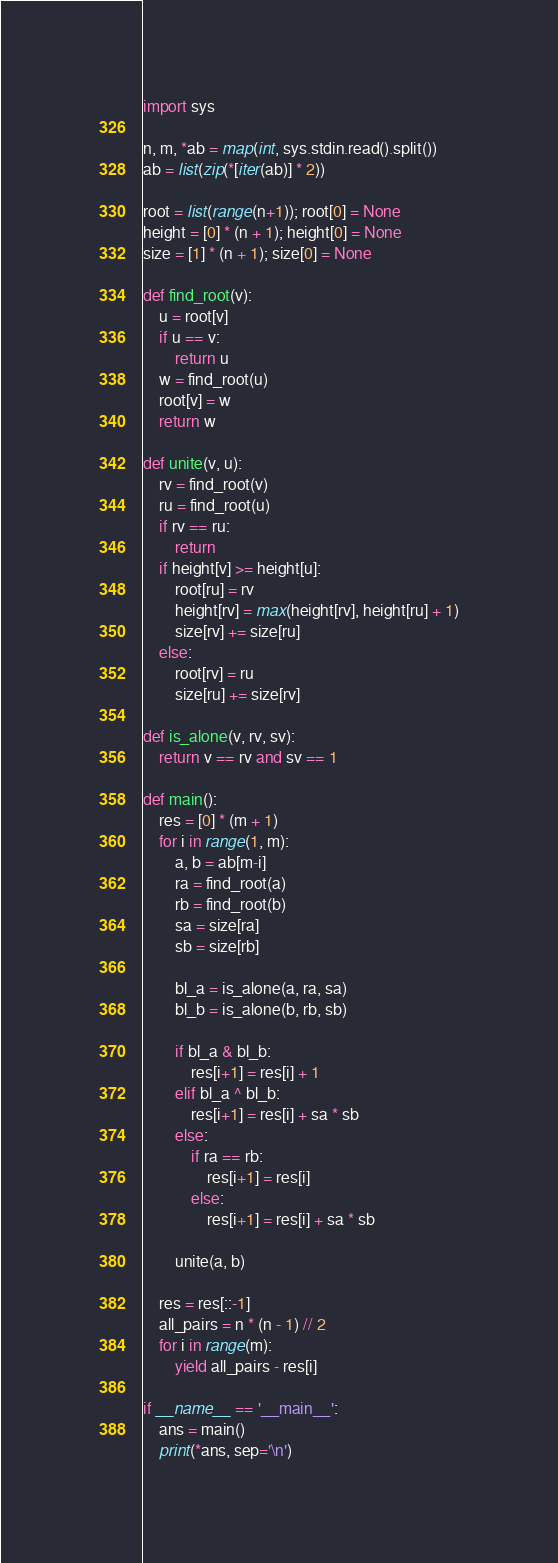Convert code to text. <code><loc_0><loc_0><loc_500><loc_500><_Python_>import sys

n, m, *ab = map(int, sys.stdin.read().split())
ab = list(zip(*[iter(ab)] * 2))

root = list(range(n+1)); root[0] = None
height = [0] * (n + 1); height[0] = None
size = [1] * (n + 1); size[0] = None

def find_root(v):
    u = root[v]
    if u == v:
        return u
    w = find_root(u)
    root[v] = w
    return w

def unite(v, u):
    rv = find_root(v)
    ru = find_root(u)
    if rv == ru:
        return
    if height[v] >= height[u]:
        root[ru] = rv
        height[rv] = max(height[rv], height[ru] + 1)
        size[rv] += size[ru]
    else:
        root[rv] = ru
        size[ru] += size[rv]

def is_alone(v, rv, sv):
    return v == rv and sv == 1

def main():
    res = [0] * (m + 1)
    for i in range(1, m):
        a, b = ab[m-i]
        ra = find_root(a)
        rb = find_root(b)
        sa = size[ra]
        sb = size[rb]
        
        bl_a = is_alone(a, ra, sa)
        bl_b = is_alone(b, rb, sb)

        if bl_a & bl_b:
            res[i+1] = res[i] + 1
        elif bl_a ^ bl_b:
            res[i+1] = res[i] + sa * sb
        else:
            if ra == rb:
                res[i+1] = res[i]
            else:
                res[i+1] = res[i] + sa * sb
        
        unite(a, b)

    res = res[::-1]
    all_pairs = n * (n - 1) // 2
    for i in range(m):
        yield all_pairs - res[i]
    
if __name__ == '__main__':
    ans = main()
    print(*ans, sep='\n')</code> 